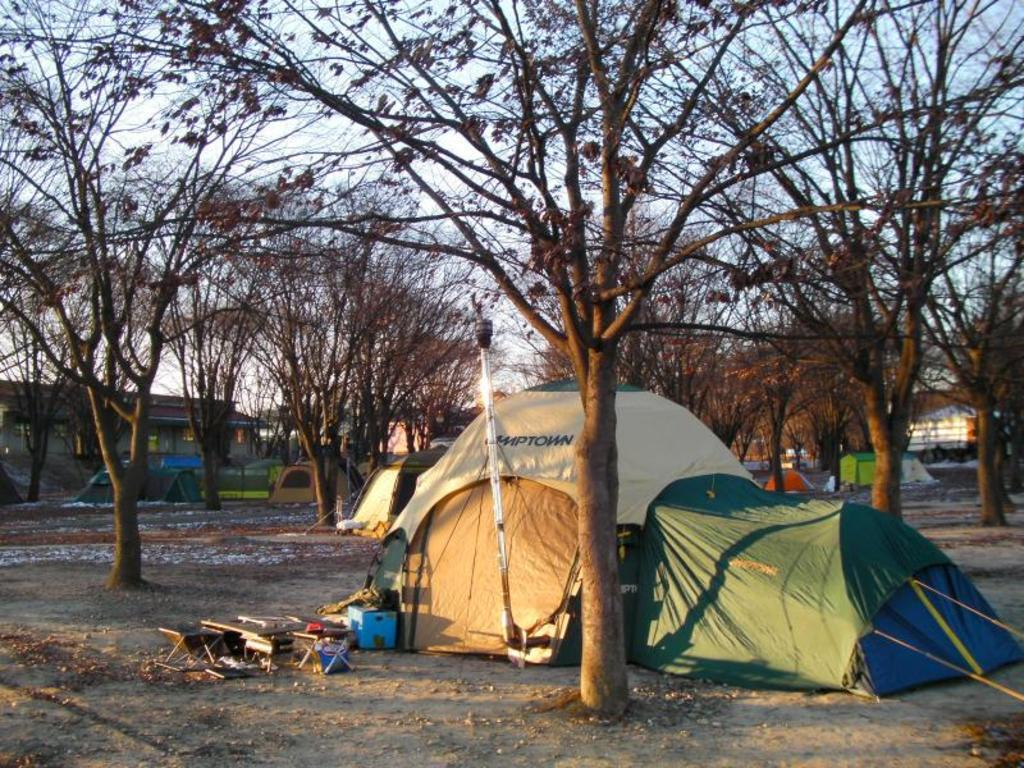What type of structures can be seen in the image? There are many tents in the image. What type of natural elements are present in the image? There are trees in the image. What can be found on the ground in the image? There are objects on the ground in the image. What is visible in the background of the image? There are houses and the sky in the background of the image. How does the zebra interact with the tents in the image? There is no zebra present in the image, so it cannot interact with the tents. 